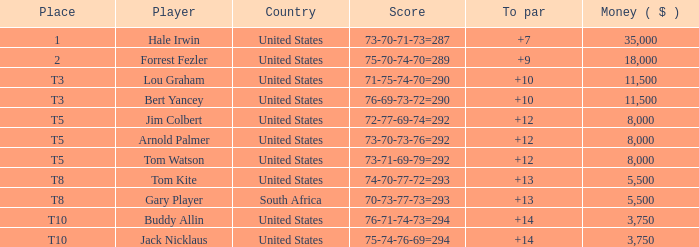Which country's score of 72-77-69-74=292 resulted in a reward of over $5,500? United States. Give me the full table as a dictionary. {'header': ['Place', 'Player', 'Country', 'Score', 'To par', 'Money ( $ )'], 'rows': [['1', 'Hale Irwin', 'United States', '73-70-71-73=287', '+7', '35,000'], ['2', 'Forrest Fezler', 'United States', '75-70-74-70=289', '+9', '18,000'], ['T3', 'Lou Graham', 'United States', '71-75-74-70=290', '+10', '11,500'], ['T3', 'Bert Yancey', 'United States', '76-69-73-72=290', '+10', '11,500'], ['T5', 'Jim Colbert', 'United States', '72-77-69-74=292', '+12', '8,000'], ['T5', 'Arnold Palmer', 'United States', '73-70-73-76=292', '+12', '8,000'], ['T5', 'Tom Watson', 'United States', '73-71-69-79=292', '+12', '8,000'], ['T8', 'Tom Kite', 'United States', '74-70-77-72=293', '+13', '5,500'], ['T8', 'Gary Player', 'South Africa', '70-73-77-73=293', '+13', '5,500'], ['T10', 'Buddy Allin', 'United States', '76-71-74-73=294', '+14', '3,750'], ['T10', 'Jack Nicklaus', 'United States', '75-74-76-69=294', '+14', '3,750']]} 